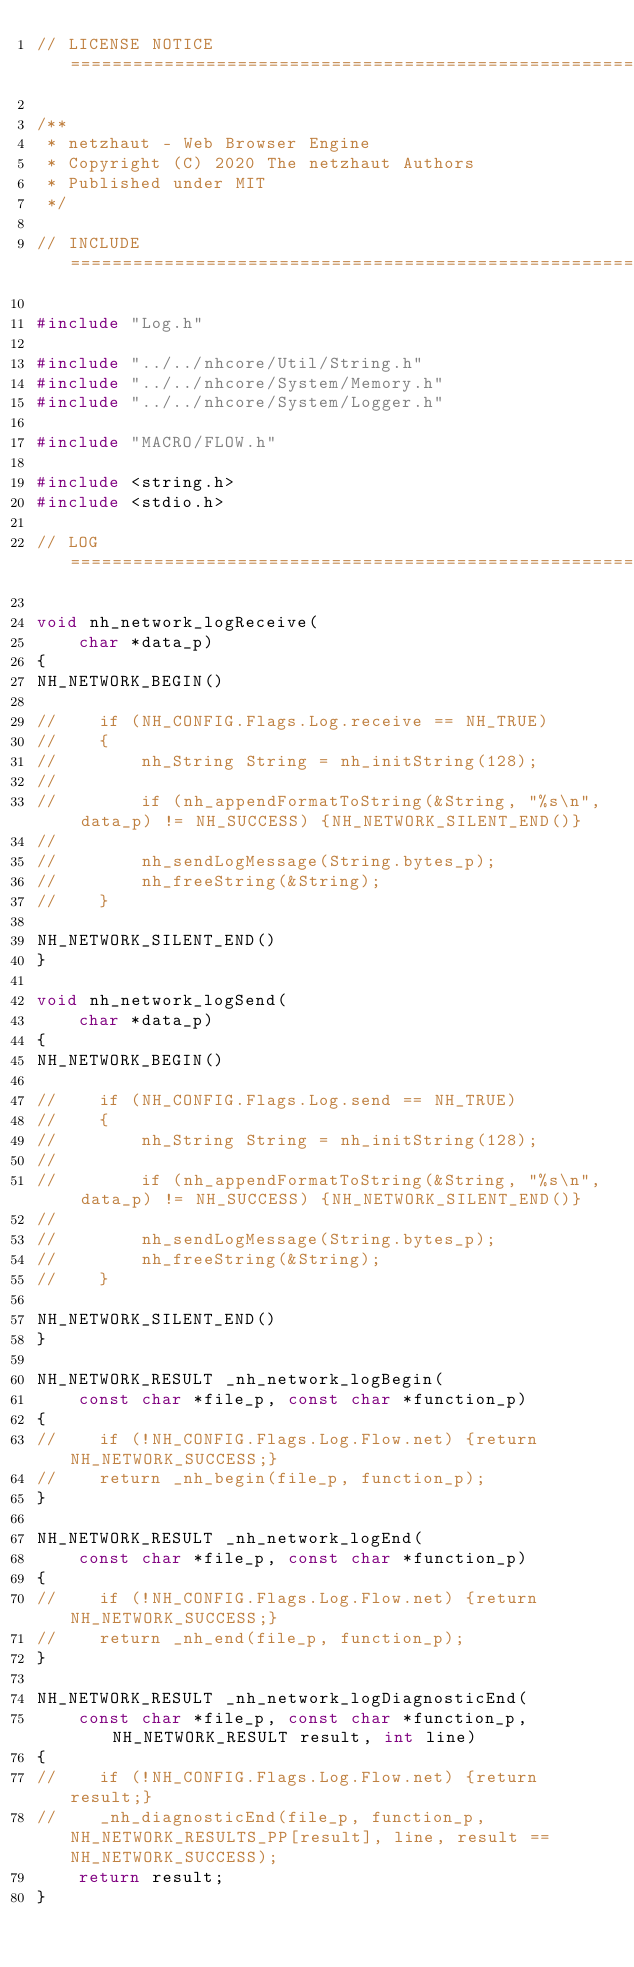Convert code to text. <code><loc_0><loc_0><loc_500><loc_500><_C_>// LICENSE NOTICE ==================================================================================

/**
 * netzhaut - Web Browser Engine
 * Copyright (C) 2020 The netzhaut Authors
 * Published under MIT
 */

// INCLUDE =========================================================================================

#include "Log.h"

#include "../../nhcore/Util/String.h"
#include "../../nhcore/System/Memory.h"
#include "../../nhcore/System/Logger.h"

#include "MACRO/FLOW.h"

#include <string.h>
#include <stdio.h>

// LOG =============================================================================================

void nh_network_logReceive(
    char *data_p)
{
NH_NETWORK_BEGIN()

//    if (NH_CONFIG.Flags.Log.receive == NH_TRUE)
//    {
//        nh_String String = nh_initString(128); 
//
//        if (nh_appendFormatToString(&String, "%s\n", data_p) != NH_SUCCESS) {NH_NETWORK_SILENT_END()}
//
//        nh_sendLogMessage(String.bytes_p);
//        nh_freeString(&String);
//    }

NH_NETWORK_SILENT_END()
}

void nh_network_logSend(
    char *data_p)
{
NH_NETWORK_BEGIN()

//    if (NH_CONFIG.Flags.Log.send == NH_TRUE)
//    {
//        nh_String String = nh_initString(128); 
//
//        if (nh_appendFormatToString(&String, "%s\n", data_p) != NH_SUCCESS) {NH_NETWORK_SILENT_END()}
//
//        nh_sendLogMessage(String.bytes_p);
//        nh_freeString(&String);
//    }

NH_NETWORK_SILENT_END()
}

NH_NETWORK_RESULT _nh_network_logBegin(
    const char *file_p, const char *function_p)
{
//    if (!NH_CONFIG.Flags.Log.Flow.net) {return NH_NETWORK_SUCCESS;}
//    return _nh_begin(file_p, function_p);
}

NH_NETWORK_RESULT _nh_network_logEnd(
    const char *file_p, const char *function_p)
{
//    if (!NH_CONFIG.Flags.Log.Flow.net) {return NH_NETWORK_SUCCESS;}
//    return _nh_end(file_p, function_p);
}

NH_NETWORK_RESULT _nh_network_logDiagnosticEnd(
    const char *file_p, const char *function_p, NH_NETWORK_RESULT result, int line)
{
//    if (!NH_CONFIG.Flags.Log.Flow.net) {return result;}
//    _nh_diagnosticEnd(file_p, function_p, NH_NETWORK_RESULTS_PP[result], line, result == NH_NETWORK_SUCCESS);
    return result;
}

</code> 